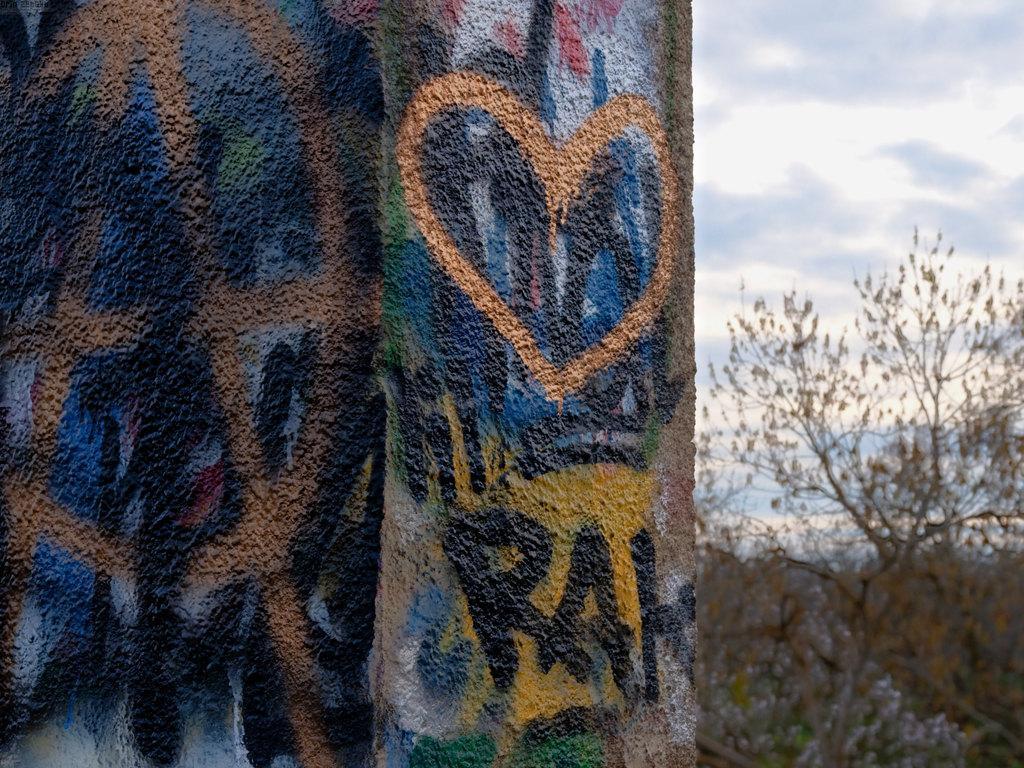Please provide a concise description of this image. On the left side of the image we can see a wall on which painting is done. On the right side of the image we can see a tree and the sky. 